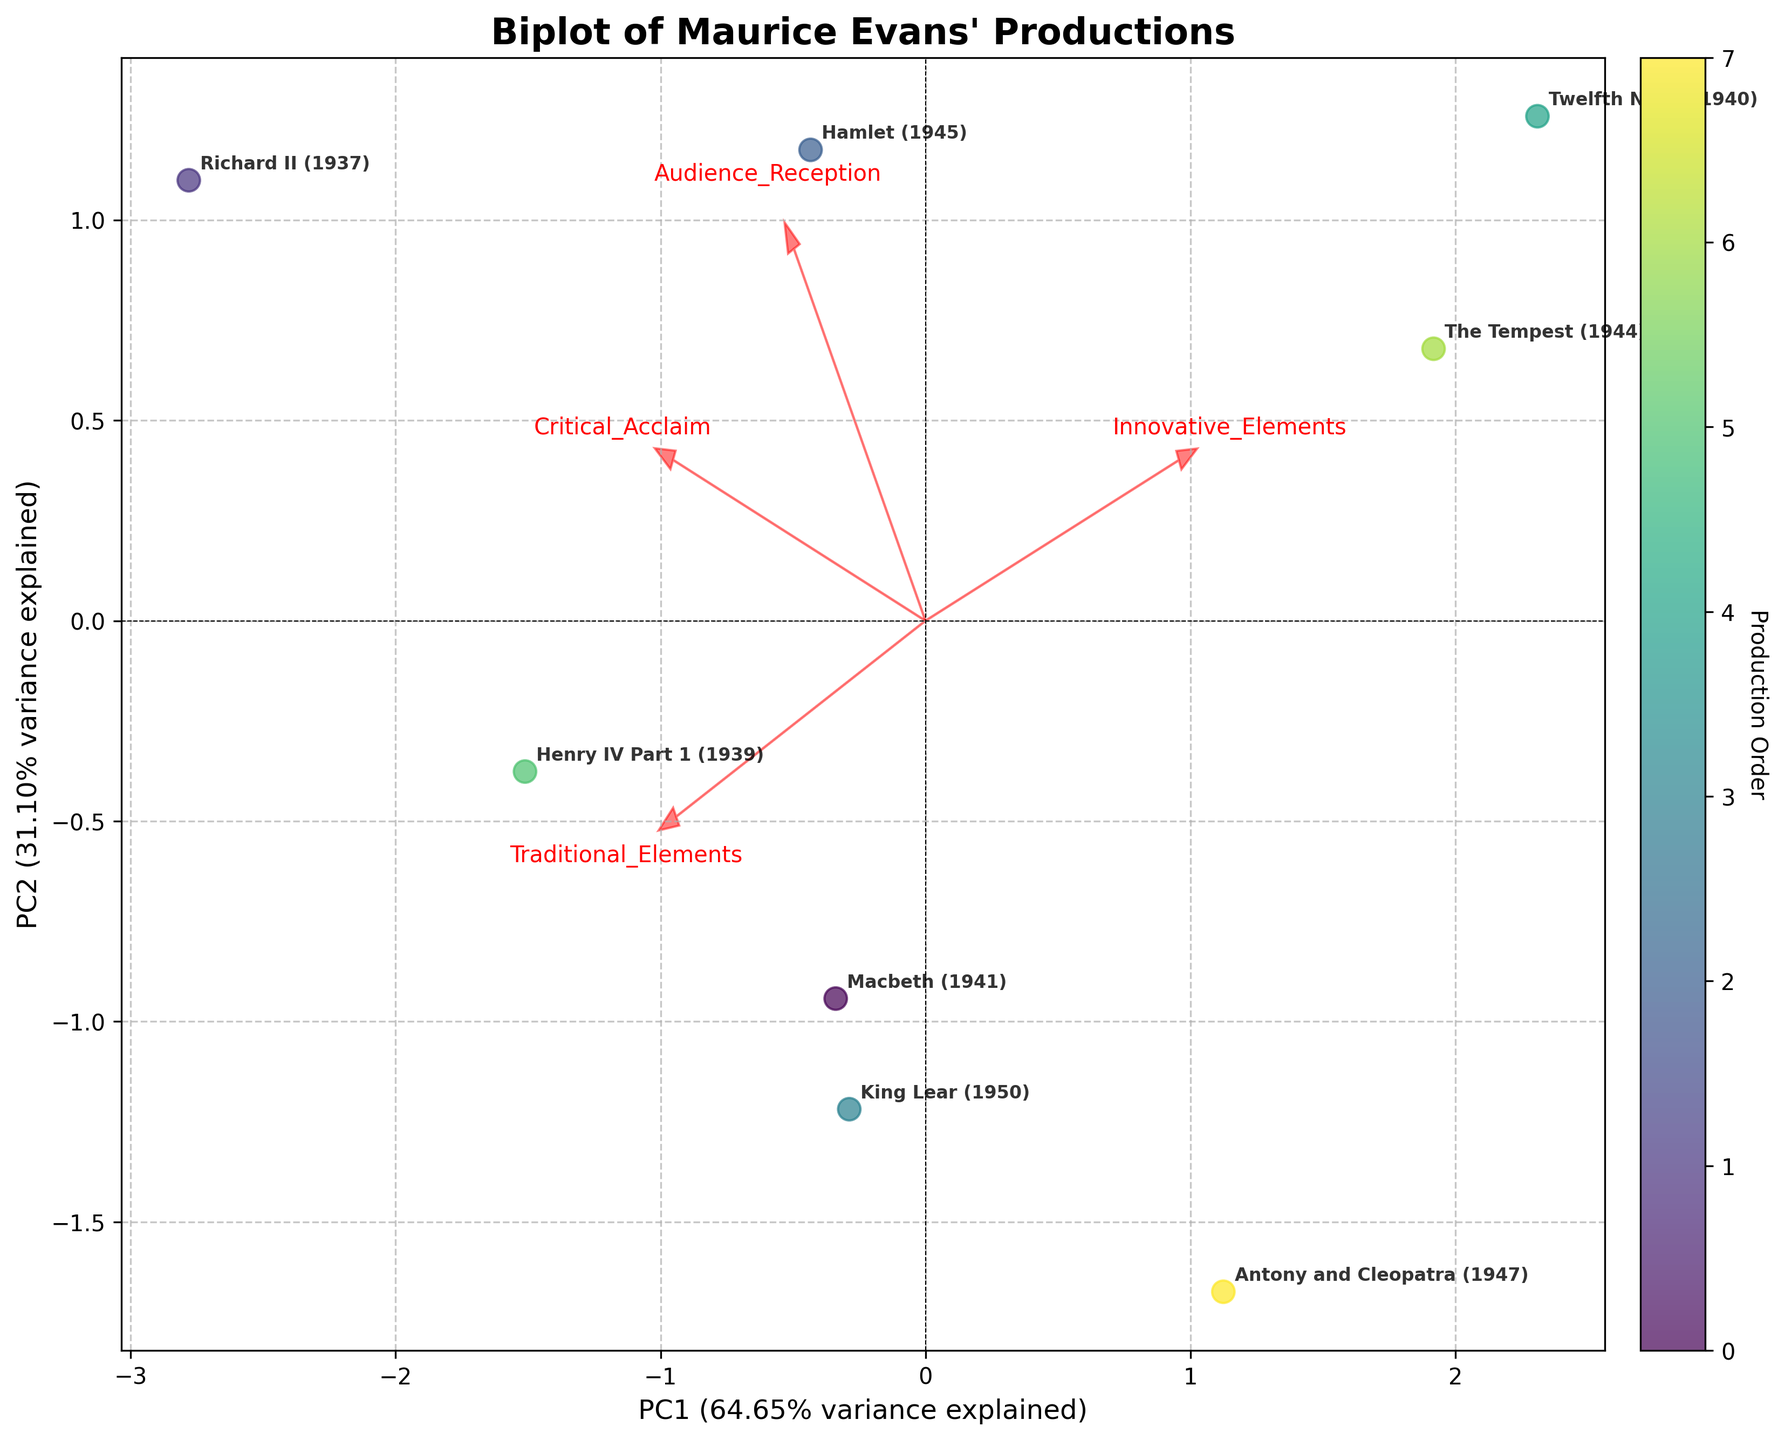What is the title of the biplot? The title of the biplot provides an overview of the data being visualized in the plot. In this case, the title summarizes the focus on Maurice Evans' productions.
Answer: Biplot of Maurice Evans' Productions How many productions are represented in the biplot? To find the number of productions, count the number of unique labels placed on the biplot. Each label represents a different production.
Answer: 8 Which production is most associated with traditional elements? To determine which production is most associated with traditional elements, look at the direction and magnitude of the loadings for 'Traditional_Elements' on the plot and find the data point closest to that vector.
Answer: Richard II (1937) Which production has the highest audience reception? Identify the data point that is closest to the direction of the 'Audience_Reception' loading vector, as this indicates the production with the highest audience reception.
Answer: Richard II (1937) What is the relationship between 'Traditional_Elements' and 'Innovative_Elements'? Interpret the angle between the vectors for 'Traditional_Elements' and 'Innovative_Elements'. A small angle suggests a positive correlation, while a large angle indicates a negative correlation.
Answer: Negative correlation Which production is closest to the origin? To find the production closest to the origin, measure the Euclidean distance from the origin (0,0) to each data point and find the shortest distance.
Answer: MacBeth (1941) Is 'Critical_Acclaim' more strongly associated with 'Traditional_Elements' or 'Innovative_Elements'? Compare the length and direction of the loadings for 'Critical_Acclaim' relative to 'Traditional_Elements' and 'Innovative_Elements' to see which has a closer vector alignment.
Answer: Traditional_Elements Which production is most associated with innovative elements? Determine the data point closest to the direction of the 'Innovative_Elements' vector to identify the production most associated with innovative elements.
Answer: The Tempest (1944) Are 'Audience_Reception' and 'Critical_Acclaim' positively or negatively correlated? Examine the angle between the vectors for 'Audience_Reception' and 'Critical_Acclaim'. A small angle indicates a positive correlation, while a larger angle indicates a negative correlation.
Answer: Positively correlated Which production has balanced attributes between traditional and innovative elements? Look for the data point that is equidistant or close to being evenly aligned between the 'Traditional_Elements' and 'Innovative_Elements' vectors.
Answer: Twelfth Night (1940) 